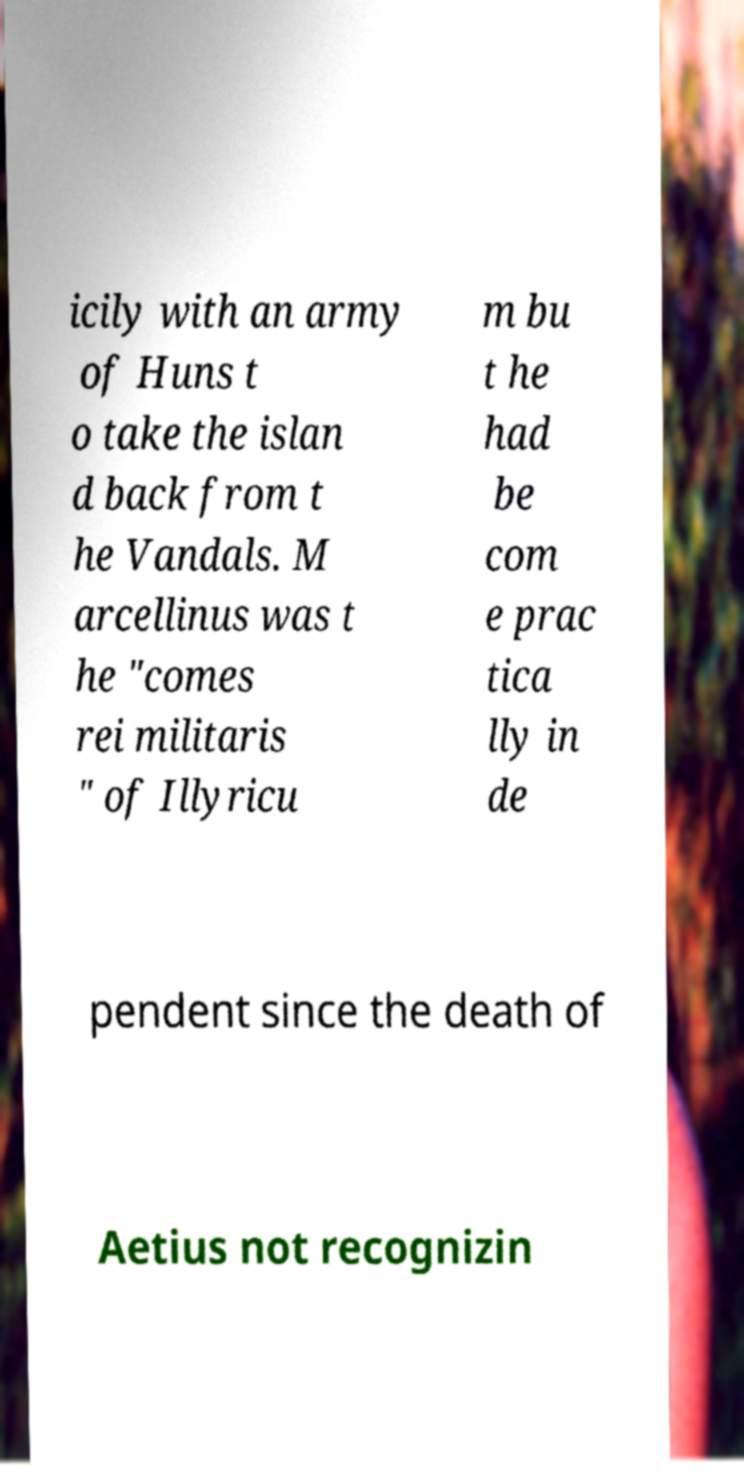What messages or text are displayed in this image? I need them in a readable, typed format. icily with an army of Huns t o take the islan d back from t he Vandals. M arcellinus was t he "comes rei militaris " of Illyricu m bu t he had be com e prac tica lly in de pendent since the death of Aetius not recognizin 